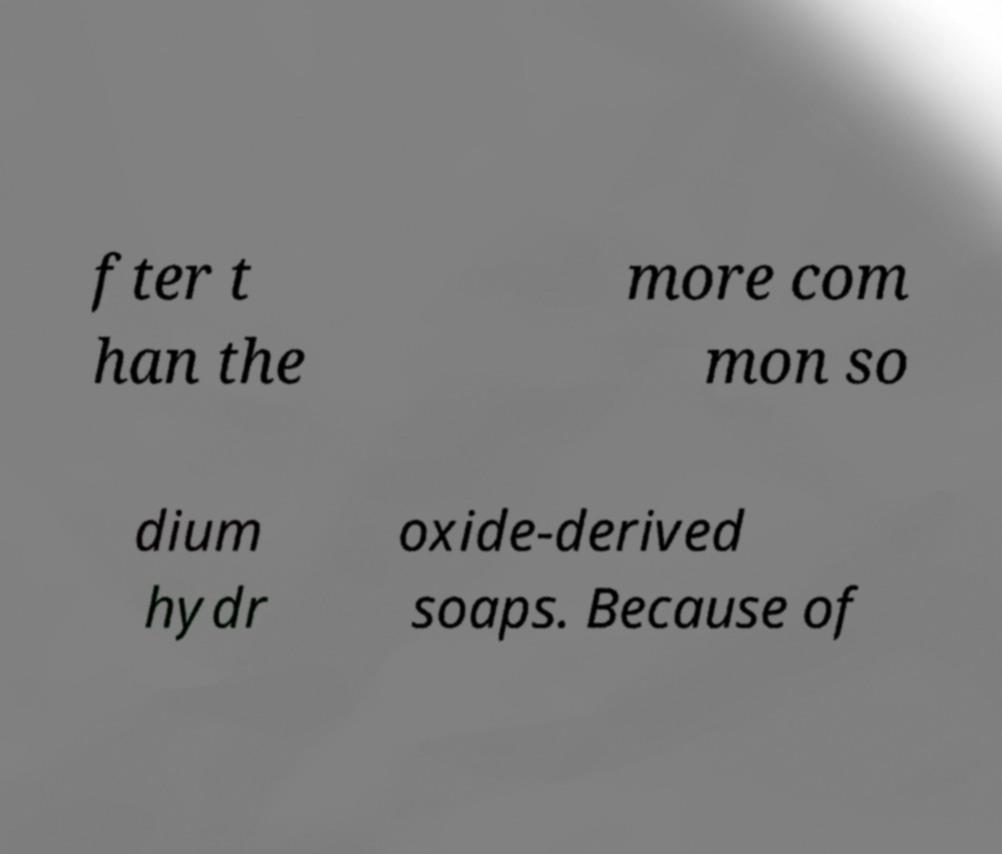There's text embedded in this image that I need extracted. Can you transcribe it verbatim? fter t han the more com mon so dium hydr oxide-derived soaps. Because of 